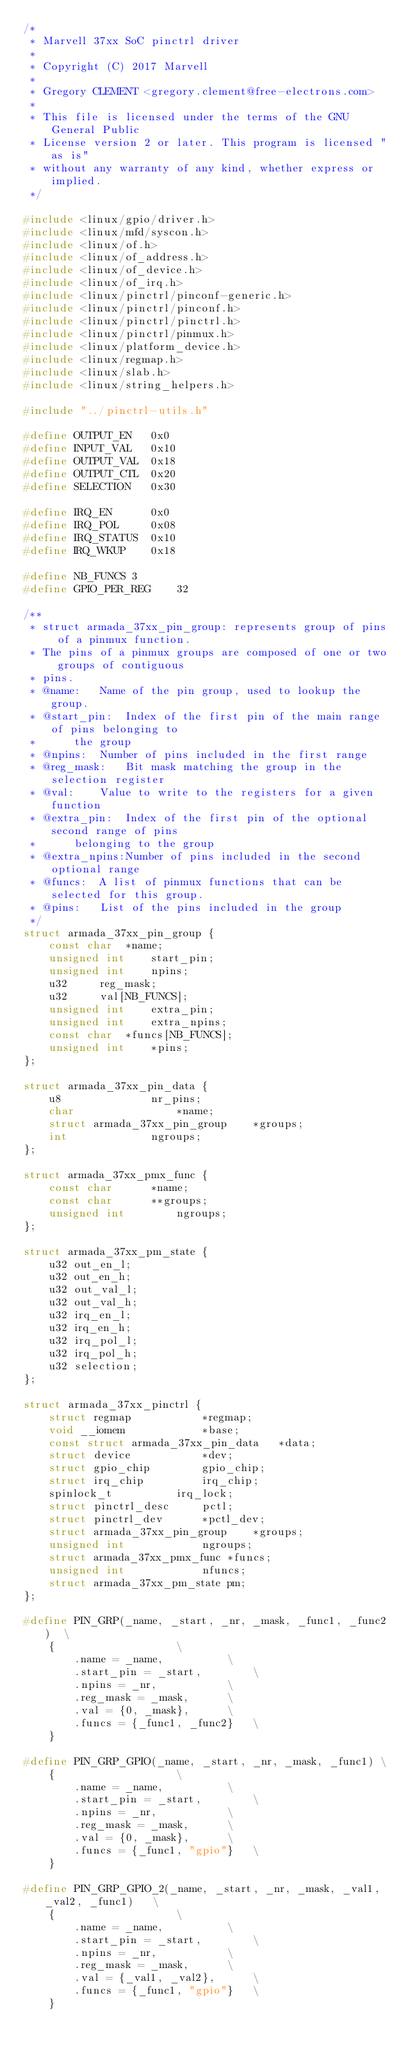<code> <loc_0><loc_0><loc_500><loc_500><_C_>/*
 * Marvell 37xx SoC pinctrl driver
 *
 * Copyright (C) 2017 Marvell
 *
 * Gregory CLEMENT <gregory.clement@free-electrons.com>
 *
 * This file is licensed under the terms of the GNU General Public
 * License version 2 or later. This program is licensed "as is"
 * without any warranty of any kind, whether express or implied.
 */

#include <linux/gpio/driver.h>
#include <linux/mfd/syscon.h>
#include <linux/of.h>
#include <linux/of_address.h>
#include <linux/of_device.h>
#include <linux/of_irq.h>
#include <linux/pinctrl/pinconf-generic.h>
#include <linux/pinctrl/pinconf.h>
#include <linux/pinctrl/pinctrl.h>
#include <linux/pinctrl/pinmux.h>
#include <linux/platform_device.h>
#include <linux/regmap.h>
#include <linux/slab.h>
#include <linux/string_helpers.h>

#include "../pinctrl-utils.h"

#define OUTPUT_EN	0x0
#define INPUT_VAL	0x10
#define OUTPUT_VAL	0x18
#define OUTPUT_CTL	0x20
#define SELECTION	0x30

#define IRQ_EN		0x0
#define IRQ_POL		0x08
#define IRQ_STATUS	0x10
#define IRQ_WKUP	0x18

#define NB_FUNCS 3
#define GPIO_PER_REG	32

/**
 * struct armada_37xx_pin_group: represents group of pins of a pinmux function.
 * The pins of a pinmux groups are composed of one or two groups of contiguous
 * pins.
 * @name:	Name of the pin group, used to lookup the group.
 * @start_pin:	Index of the first pin of the main range of pins belonging to
 *		the group
 * @npins:	Number of pins included in the first range
 * @reg_mask:	Bit mask matching the group in the selection register
 * @val:	Value to write to the registers for a given function
 * @extra_pin:	Index of the first pin of the optional second range of pins
 *		belonging to the group
 * @extra_npins:Number of pins included in the second optional range
 * @funcs:	A list of pinmux functions that can be selected for this group.
 * @pins:	List of the pins included in the group
 */
struct armada_37xx_pin_group {
	const char	*name;
	unsigned int	start_pin;
	unsigned int	npins;
	u32		reg_mask;
	u32		val[NB_FUNCS];
	unsigned int	extra_pin;
	unsigned int	extra_npins;
	const char	*funcs[NB_FUNCS];
	unsigned int	*pins;
};

struct armada_37xx_pin_data {
	u8				nr_pins;
	char				*name;
	struct armada_37xx_pin_group	*groups;
	int				ngroups;
};

struct armada_37xx_pmx_func {
	const char		*name;
	const char		**groups;
	unsigned int		ngroups;
};

struct armada_37xx_pm_state {
	u32 out_en_l;
	u32 out_en_h;
	u32 out_val_l;
	u32 out_val_h;
	u32 irq_en_l;
	u32 irq_en_h;
	u32 irq_pol_l;
	u32 irq_pol_h;
	u32 selection;
};

struct armada_37xx_pinctrl {
	struct regmap			*regmap;
	void __iomem			*base;
	const struct armada_37xx_pin_data	*data;
	struct device			*dev;
	struct gpio_chip		gpio_chip;
	struct irq_chip			irq_chip;
	spinlock_t			irq_lock;
	struct pinctrl_desc		pctl;
	struct pinctrl_dev		*pctl_dev;
	struct armada_37xx_pin_group	*groups;
	unsigned int			ngroups;
	struct armada_37xx_pmx_func	*funcs;
	unsigned int			nfuncs;
	struct armada_37xx_pm_state	pm;
};

#define PIN_GRP(_name, _start, _nr, _mask, _func1, _func2)	\
	{					\
		.name = _name,			\
		.start_pin = _start,		\
		.npins = _nr,			\
		.reg_mask = _mask,		\
		.val = {0, _mask},		\
		.funcs = {_func1, _func2}	\
	}

#define PIN_GRP_GPIO(_name, _start, _nr, _mask, _func1)	\
	{					\
		.name = _name,			\
		.start_pin = _start,		\
		.npins = _nr,			\
		.reg_mask = _mask,		\
		.val = {0, _mask},		\
		.funcs = {_func1, "gpio"}	\
	}

#define PIN_GRP_GPIO_2(_name, _start, _nr, _mask, _val1, _val2, _func1)   \
	{					\
		.name = _name,			\
		.start_pin = _start,		\
		.npins = _nr,			\
		.reg_mask = _mask,		\
		.val = {_val1, _val2},		\
		.funcs = {_func1, "gpio"}	\
	}
</code> 